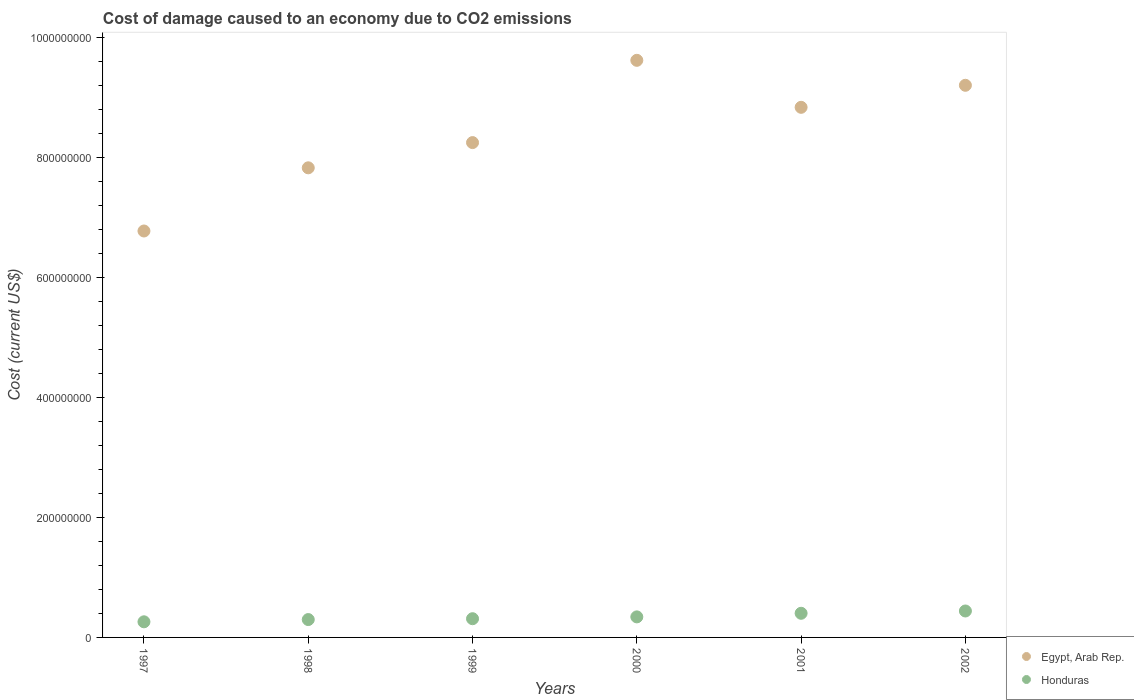Is the number of dotlines equal to the number of legend labels?
Provide a succinct answer. Yes. What is the cost of damage caused due to CO2 emissisons in Honduras in 2001?
Provide a succinct answer. 4.03e+07. Across all years, what is the maximum cost of damage caused due to CO2 emissisons in Honduras?
Offer a terse response. 4.41e+07. Across all years, what is the minimum cost of damage caused due to CO2 emissisons in Egypt, Arab Rep.?
Make the answer very short. 6.78e+08. In which year was the cost of damage caused due to CO2 emissisons in Honduras minimum?
Offer a very short reply. 1997. What is the total cost of damage caused due to CO2 emissisons in Honduras in the graph?
Offer a very short reply. 2.06e+08. What is the difference between the cost of damage caused due to CO2 emissisons in Honduras in 1999 and that in 2002?
Your answer should be compact. -1.29e+07. What is the difference between the cost of damage caused due to CO2 emissisons in Egypt, Arab Rep. in 1999 and the cost of damage caused due to CO2 emissisons in Honduras in 2001?
Give a very brief answer. 7.85e+08. What is the average cost of damage caused due to CO2 emissisons in Honduras per year?
Your answer should be compact. 3.43e+07. In the year 1999, what is the difference between the cost of damage caused due to CO2 emissisons in Egypt, Arab Rep. and cost of damage caused due to CO2 emissisons in Honduras?
Offer a very short reply. 7.94e+08. What is the ratio of the cost of damage caused due to CO2 emissisons in Egypt, Arab Rep. in 1997 to that in 1999?
Your answer should be very brief. 0.82. Is the cost of damage caused due to CO2 emissisons in Egypt, Arab Rep. in 1998 less than that in 1999?
Offer a terse response. Yes. Is the difference between the cost of damage caused due to CO2 emissisons in Egypt, Arab Rep. in 2000 and 2001 greater than the difference between the cost of damage caused due to CO2 emissisons in Honduras in 2000 and 2001?
Give a very brief answer. Yes. What is the difference between the highest and the second highest cost of damage caused due to CO2 emissisons in Honduras?
Your answer should be compact. 3.83e+06. What is the difference between the highest and the lowest cost of damage caused due to CO2 emissisons in Honduras?
Provide a short and direct response. 1.80e+07. Is the sum of the cost of damage caused due to CO2 emissisons in Egypt, Arab Rep. in 1998 and 2000 greater than the maximum cost of damage caused due to CO2 emissisons in Honduras across all years?
Provide a short and direct response. Yes. Is the cost of damage caused due to CO2 emissisons in Honduras strictly greater than the cost of damage caused due to CO2 emissisons in Egypt, Arab Rep. over the years?
Offer a terse response. No. How many years are there in the graph?
Your answer should be compact. 6. What is the difference between two consecutive major ticks on the Y-axis?
Your answer should be compact. 2.00e+08. Does the graph contain any zero values?
Your answer should be compact. No. How many legend labels are there?
Provide a succinct answer. 2. How are the legend labels stacked?
Offer a terse response. Vertical. What is the title of the graph?
Give a very brief answer. Cost of damage caused to an economy due to CO2 emissions. Does "Niger" appear as one of the legend labels in the graph?
Your answer should be compact. No. What is the label or title of the X-axis?
Offer a terse response. Years. What is the label or title of the Y-axis?
Ensure brevity in your answer.  Cost (current US$). What is the Cost (current US$) of Egypt, Arab Rep. in 1997?
Give a very brief answer. 6.78e+08. What is the Cost (current US$) of Honduras in 1997?
Offer a terse response. 2.61e+07. What is the Cost (current US$) of Egypt, Arab Rep. in 1998?
Your response must be concise. 7.83e+08. What is the Cost (current US$) of Honduras in 1998?
Offer a very short reply. 2.98e+07. What is the Cost (current US$) in Egypt, Arab Rep. in 1999?
Give a very brief answer. 8.25e+08. What is the Cost (current US$) in Honduras in 1999?
Give a very brief answer. 3.12e+07. What is the Cost (current US$) of Egypt, Arab Rep. in 2000?
Provide a succinct answer. 9.63e+08. What is the Cost (current US$) in Honduras in 2000?
Give a very brief answer. 3.43e+07. What is the Cost (current US$) of Egypt, Arab Rep. in 2001?
Keep it short and to the point. 8.84e+08. What is the Cost (current US$) of Honduras in 2001?
Your response must be concise. 4.03e+07. What is the Cost (current US$) in Egypt, Arab Rep. in 2002?
Make the answer very short. 9.21e+08. What is the Cost (current US$) of Honduras in 2002?
Your answer should be very brief. 4.41e+07. Across all years, what is the maximum Cost (current US$) in Egypt, Arab Rep.?
Keep it short and to the point. 9.63e+08. Across all years, what is the maximum Cost (current US$) in Honduras?
Your response must be concise. 4.41e+07. Across all years, what is the minimum Cost (current US$) in Egypt, Arab Rep.?
Your response must be concise. 6.78e+08. Across all years, what is the minimum Cost (current US$) of Honduras?
Keep it short and to the point. 2.61e+07. What is the total Cost (current US$) of Egypt, Arab Rep. in the graph?
Provide a short and direct response. 5.05e+09. What is the total Cost (current US$) of Honduras in the graph?
Make the answer very short. 2.06e+08. What is the difference between the Cost (current US$) of Egypt, Arab Rep. in 1997 and that in 1998?
Your answer should be very brief. -1.05e+08. What is the difference between the Cost (current US$) of Honduras in 1997 and that in 1998?
Offer a very short reply. -3.74e+06. What is the difference between the Cost (current US$) of Egypt, Arab Rep. in 1997 and that in 1999?
Offer a terse response. -1.47e+08. What is the difference between the Cost (current US$) of Honduras in 1997 and that in 1999?
Ensure brevity in your answer.  -5.16e+06. What is the difference between the Cost (current US$) in Egypt, Arab Rep. in 1997 and that in 2000?
Your answer should be very brief. -2.85e+08. What is the difference between the Cost (current US$) of Honduras in 1997 and that in 2000?
Provide a short and direct response. -8.21e+06. What is the difference between the Cost (current US$) of Egypt, Arab Rep. in 1997 and that in 2001?
Offer a terse response. -2.06e+08. What is the difference between the Cost (current US$) in Honduras in 1997 and that in 2001?
Keep it short and to the point. -1.42e+07. What is the difference between the Cost (current US$) of Egypt, Arab Rep. in 1997 and that in 2002?
Your answer should be very brief. -2.43e+08. What is the difference between the Cost (current US$) in Honduras in 1997 and that in 2002?
Your answer should be compact. -1.80e+07. What is the difference between the Cost (current US$) in Egypt, Arab Rep. in 1998 and that in 1999?
Your response must be concise. -4.21e+07. What is the difference between the Cost (current US$) of Honduras in 1998 and that in 1999?
Offer a very short reply. -1.41e+06. What is the difference between the Cost (current US$) of Egypt, Arab Rep. in 1998 and that in 2000?
Give a very brief answer. -1.79e+08. What is the difference between the Cost (current US$) in Honduras in 1998 and that in 2000?
Provide a succinct answer. -4.47e+06. What is the difference between the Cost (current US$) in Egypt, Arab Rep. in 1998 and that in 2001?
Offer a terse response. -1.01e+08. What is the difference between the Cost (current US$) in Honduras in 1998 and that in 2001?
Offer a terse response. -1.05e+07. What is the difference between the Cost (current US$) in Egypt, Arab Rep. in 1998 and that in 2002?
Provide a succinct answer. -1.38e+08. What is the difference between the Cost (current US$) of Honduras in 1998 and that in 2002?
Make the answer very short. -1.43e+07. What is the difference between the Cost (current US$) of Egypt, Arab Rep. in 1999 and that in 2000?
Ensure brevity in your answer.  -1.37e+08. What is the difference between the Cost (current US$) in Honduras in 1999 and that in 2000?
Your response must be concise. -3.06e+06. What is the difference between the Cost (current US$) of Egypt, Arab Rep. in 1999 and that in 2001?
Your answer should be compact. -5.88e+07. What is the difference between the Cost (current US$) in Honduras in 1999 and that in 2001?
Provide a short and direct response. -9.06e+06. What is the difference between the Cost (current US$) in Egypt, Arab Rep. in 1999 and that in 2002?
Offer a terse response. -9.56e+07. What is the difference between the Cost (current US$) in Honduras in 1999 and that in 2002?
Your answer should be compact. -1.29e+07. What is the difference between the Cost (current US$) of Egypt, Arab Rep. in 2000 and that in 2001?
Your answer should be compact. 7.84e+07. What is the difference between the Cost (current US$) in Honduras in 2000 and that in 2001?
Provide a succinct answer. -6.00e+06. What is the difference between the Cost (current US$) of Egypt, Arab Rep. in 2000 and that in 2002?
Your response must be concise. 4.16e+07. What is the difference between the Cost (current US$) in Honduras in 2000 and that in 2002?
Give a very brief answer. -9.83e+06. What is the difference between the Cost (current US$) in Egypt, Arab Rep. in 2001 and that in 2002?
Make the answer very short. -3.67e+07. What is the difference between the Cost (current US$) in Honduras in 2001 and that in 2002?
Provide a short and direct response. -3.83e+06. What is the difference between the Cost (current US$) in Egypt, Arab Rep. in 1997 and the Cost (current US$) in Honduras in 1998?
Your response must be concise. 6.48e+08. What is the difference between the Cost (current US$) in Egypt, Arab Rep. in 1997 and the Cost (current US$) in Honduras in 1999?
Provide a succinct answer. 6.47e+08. What is the difference between the Cost (current US$) of Egypt, Arab Rep. in 1997 and the Cost (current US$) of Honduras in 2000?
Provide a short and direct response. 6.44e+08. What is the difference between the Cost (current US$) of Egypt, Arab Rep. in 1997 and the Cost (current US$) of Honduras in 2001?
Offer a terse response. 6.38e+08. What is the difference between the Cost (current US$) in Egypt, Arab Rep. in 1997 and the Cost (current US$) in Honduras in 2002?
Offer a very short reply. 6.34e+08. What is the difference between the Cost (current US$) of Egypt, Arab Rep. in 1998 and the Cost (current US$) of Honduras in 1999?
Your response must be concise. 7.52e+08. What is the difference between the Cost (current US$) in Egypt, Arab Rep. in 1998 and the Cost (current US$) in Honduras in 2000?
Your response must be concise. 7.49e+08. What is the difference between the Cost (current US$) of Egypt, Arab Rep. in 1998 and the Cost (current US$) of Honduras in 2001?
Your answer should be very brief. 7.43e+08. What is the difference between the Cost (current US$) in Egypt, Arab Rep. in 1998 and the Cost (current US$) in Honduras in 2002?
Your answer should be compact. 7.39e+08. What is the difference between the Cost (current US$) of Egypt, Arab Rep. in 1999 and the Cost (current US$) of Honduras in 2000?
Give a very brief answer. 7.91e+08. What is the difference between the Cost (current US$) of Egypt, Arab Rep. in 1999 and the Cost (current US$) of Honduras in 2001?
Ensure brevity in your answer.  7.85e+08. What is the difference between the Cost (current US$) of Egypt, Arab Rep. in 1999 and the Cost (current US$) of Honduras in 2002?
Your answer should be very brief. 7.81e+08. What is the difference between the Cost (current US$) in Egypt, Arab Rep. in 2000 and the Cost (current US$) in Honduras in 2001?
Ensure brevity in your answer.  9.22e+08. What is the difference between the Cost (current US$) of Egypt, Arab Rep. in 2000 and the Cost (current US$) of Honduras in 2002?
Your answer should be compact. 9.18e+08. What is the difference between the Cost (current US$) in Egypt, Arab Rep. in 2001 and the Cost (current US$) in Honduras in 2002?
Offer a terse response. 8.40e+08. What is the average Cost (current US$) in Egypt, Arab Rep. per year?
Your answer should be compact. 8.42e+08. What is the average Cost (current US$) in Honduras per year?
Offer a terse response. 3.43e+07. In the year 1997, what is the difference between the Cost (current US$) in Egypt, Arab Rep. and Cost (current US$) in Honduras?
Your answer should be compact. 6.52e+08. In the year 1998, what is the difference between the Cost (current US$) in Egypt, Arab Rep. and Cost (current US$) in Honduras?
Ensure brevity in your answer.  7.53e+08. In the year 1999, what is the difference between the Cost (current US$) in Egypt, Arab Rep. and Cost (current US$) in Honduras?
Ensure brevity in your answer.  7.94e+08. In the year 2000, what is the difference between the Cost (current US$) in Egypt, Arab Rep. and Cost (current US$) in Honduras?
Your answer should be compact. 9.28e+08. In the year 2001, what is the difference between the Cost (current US$) in Egypt, Arab Rep. and Cost (current US$) in Honduras?
Offer a terse response. 8.44e+08. In the year 2002, what is the difference between the Cost (current US$) in Egypt, Arab Rep. and Cost (current US$) in Honduras?
Provide a short and direct response. 8.77e+08. What is the ratio of the Cost (current US$) of Egypt, Arab Rep. in 1997 to that in 1998?
Your response must be concise. 0.87. What is the ratio of the Cost (current US$) of Honduras in 1997 to that in 1998?
Your response must be concise. 0.87. What is the ratio of the Cost (current US$) in Egypt, Arab Rep. in 1997 to that in 1999?
Your answer should be compact. 0.82. What is the ratio of the Cost (current US$) of Honduras in 1997 to that in 1999?
Provide a short and direct response. 0.83. What is the ratio of the Cost (current US$) of Egypt, Arab Rep. in 1997 to that in 2000?
Give a very brief answer. 0.7. What is the ratio of the Cost (current US$) in Honduras in 1997 to that in 2000?
Ensure brevity in your answer.  0.76. What is the ratio of the Cost (current US$) in Egypt, Arab Rep. in 1997 to that in 2001?
Give a very brief answer. 0.77. What is the ratio of the Cost (current US$) of Honduras in 1997 to that in 2001?
Give a very brief answer. 0.65. What is the ratio of the Cost (current US$) in Egypt, Arab Rep. in 1997 to that in 2002?
Your answer should be very brief. 0.74. What is the ratio of the Cost (current US$) of Honduras in 1997 to that in 2002?
Provide a succinct answer. 0.59. What is the ratio of the Cost (current US$) in Egypt, Arab Rep. in 1998 to that in 1999?
Make the answer very short. 0.95. What is the ratio of the Cost (current US$) of Honduras in 1998 to that in 1999?
Offer a terse response. 0.95. What is the ratio of the Cost (current US$) of Egypt, Arab Rep. in 1998 to that in 2000?
Your answer should be very brief. 0.81. What is the ratio of the Cost (current US$) in Honduras in 1998 to that in 2000?
Your answer should be very brief. 0.87. What is the ratio of the Cost (current US$) in Egypt, Arab Rep. in 1998 to that in 2001?
Ensure brevity in your answer.  0.89. What is the ratio of the Cost (current US$) in Honduras in 1998 to that in 2001?
Your answer should be very brief. 0.74. What is the ratio of the Cost (current US$) in Egypt, Arab Rep. in 1998 to that in 2002?
Your answer should be compact. 0.85. What is the ratio of the Cost (current US$) of Honduras in 1998 to that in 2002?
Your answer should be very brief. 0.68. What is the ratio of the Cost (current US$) of Egypt, Arab Rep. in 1999 to that in 2000?
Make the answer very short. 0.86. What is the ratio of the Cost (current US$) in Honduras in 1999 to that in 2000?
Your answer should be compact. 0.91. What is the ratio of the Cost (current US$) in Egypt, Arab Rep. in 1999 to that in 2001?
Give a very brief answer. 0.93. What is the ratio of the Cost (current US$) in Honduras in 1999 to that in 2001?
Keep it short and to the point. 0.78. What is the ratio of the Cost (current US$) in Egypt, Arab Rep. in 1999 to that in 2002?
Give a very brief answer. 0.9. What is the ratio of the Cost (current US$) in Honduras in 1999 to that in 2002?
Your answer should be compact. 0.71. What is the ratio of the Cost (current US$) in Egypt, Arab Rep. in 2000 to that in 2001?
Keep it short and to the point. 1.09. What is the ratio of the Cost (current US$) of Honduras in 2000 to that in 2001?
Keep it short and to the point. 0.85. What is the ratio of the Cost (current US$) in Egypt, Arab Rep. in 2000 to that in 2002?
Your answer should be very brief. 1.05. What is the ratio of the Cost (current US$) of Honduras in 2000 to that in 2002?
Provide a short and direct response. 0.78. What is the ratio of the Cost (current US$) in Egypt, Arab Rep. in 2001 to that in 2002?
Make the answer very short. 0.96. What is the ratio of the Cost (current US$) of Honduras in 2001 to that in 2002?
Your answer should be compact. 0.91. What is the difference between the highest and the second highest Cost (current US$) of Egypt, Arab Rep.?
Keep it short and to the point. 4.16e+07. What is the difference between the highest and the second highest Cost (current US$) in Honduras?
Give a very brief answer. 3.83e+06. What is the difference between the highest and the lowest Cost (current US$) in Egypt, Arab Rep.?
Make the answer very short. 2.85e+08. What is the difference between the highest and the lowest Cost (current US$) of Honduras?
Keep it short and to the point. 1.80e+07. 